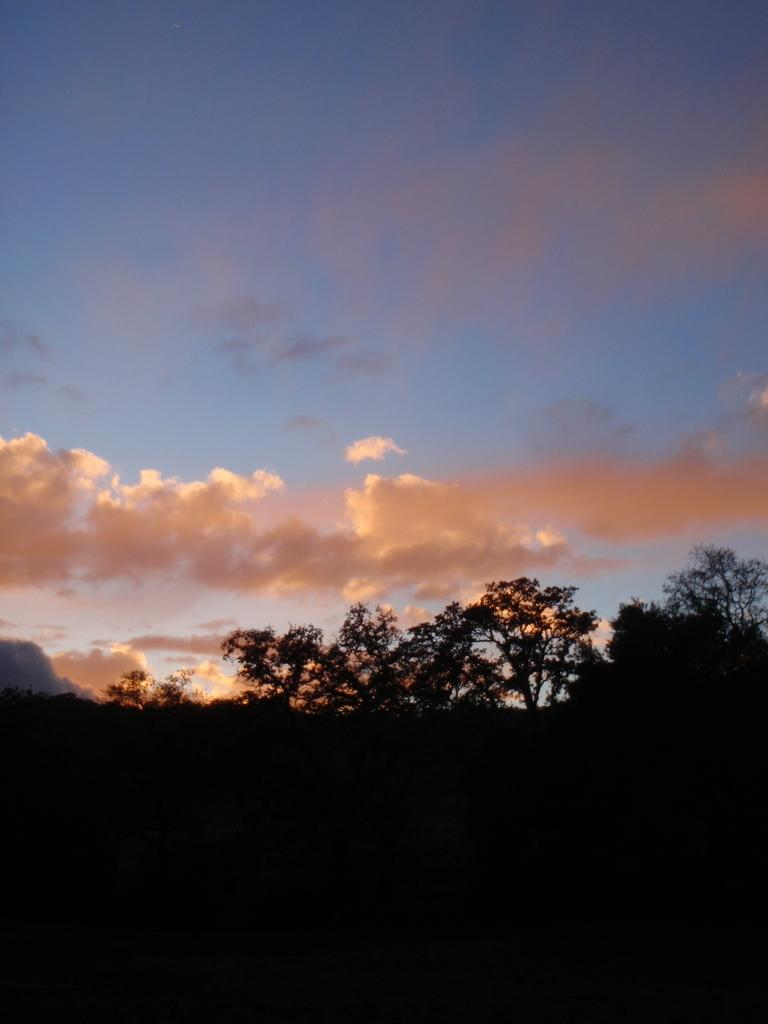What type of vegetation can be seen in the image? There are trees in the image. What can be seen in the sky in the background of the image? There are clouds in the sky in the background of the image. What type of health request is being made by the flower in the image? There is no flower present in the image, so no health request can be made. 